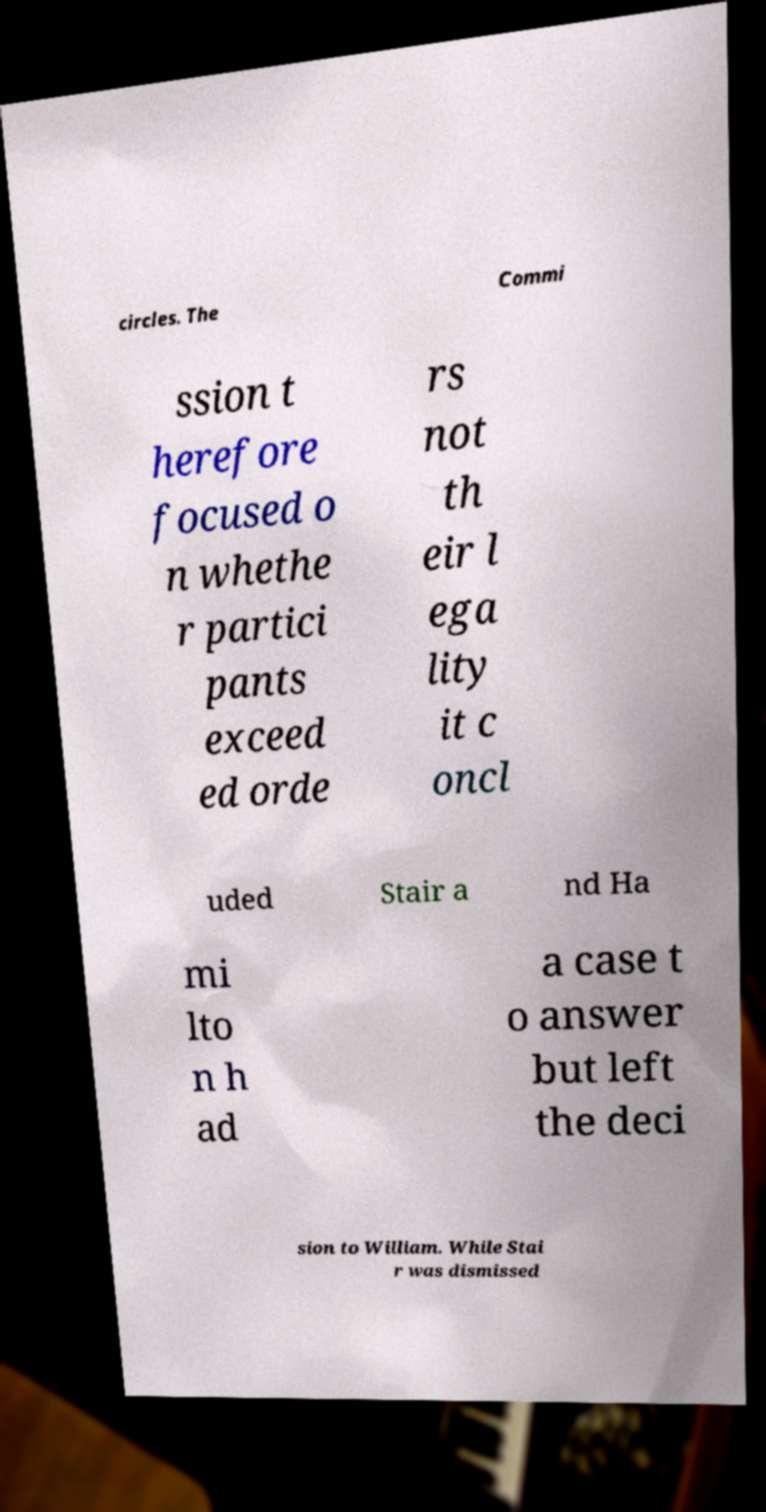Can you read and provide the text displayed in the image?This photo seems to have some interesting text. Can you extract and type it out for me? circles. The Commi ssion t herefore focused o n whethe r partici pants exceed ed orde rs not th eir l ega lity it c oncl uded Stair a nd Ha mi lto n h ad a case t o answer but left the deci sion to William. While Stai r was dismissed 